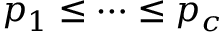Convert formula to latex. <formula><loc_0><loc_0><loc_500><loc_500>p _ { 1 } \leq \cdots \leq p _ { c }</formula> 